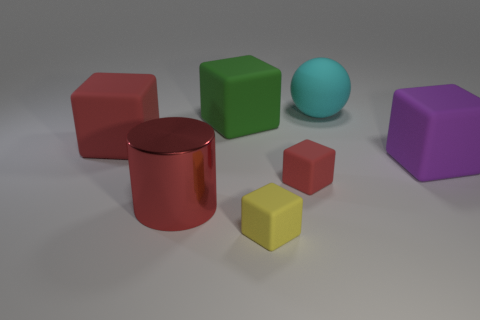Is there any other thing that has the same material as the red cylinder?
Provide a succinct answer. No. Is the color of the large metallic thing the same as the large matte sphere?
Provide a succinct answer. No. What number of objects are either rubber blocks behind the tiny red rubber block or cylinders?
Make the answer very short. 4. How many rubber blocks are behind the tiny rubber object that is to the left of the tiny thing behind the large red shiny cylinder?
Make the answer very short. 4. Is there anything else that has the same size as the cyan object?
Provide a succinct answer. Yes. What is the shape of the large thing in front of the large matte block on the right side of the tiny matte thing on the right side of the tiny yellow rubber block?
Make the answer very short. Cylinder. How many other things are the same color as the big cylinder?
Make the answer very short. 2. The large red thing that is to the right of the large block to the left of the green rubber block is what shape?
Your answer should be compact. Cylinder. How many metallic cylinders are left of the small yellow thing?
Your answer should be very brief. 1. Is there a big green object made of the same material as the purple thing?
Keep it short and to the point. Yes. 